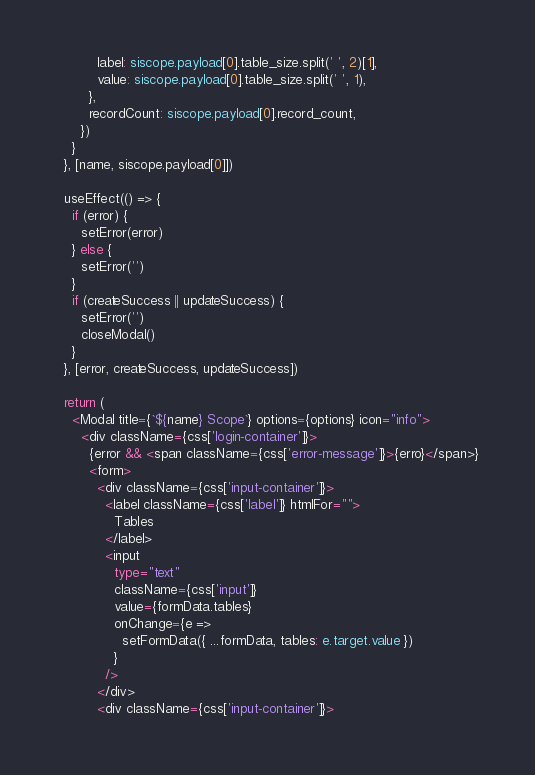Convert code to text. <code><loc_0><loc_0><loc_500><loc_500><_TypeScript_>          label: siscope.payload[0].table_size.split(' ', 2)[1],
          value: siscope.payload[0].table_size.split(' ', 1),
        },
        recordCount: siscope.payload[0].record_count,
      })
    }
  }, [name, siscope.payload[0]])

  useEffect(() => {
    if (error) {
      setError(error)
    } else {
      setError('')
    }
    if (createSuccess || updateSuccess) {
      setError('')
      closeModal()
    }
  }, [error, createSuccess, updateSuccess])

  return (
    <Modal title={`${name} Scope`} options={options} icon="info">
      <div className={css['login-container']}>
        {error && <span className={css['error-message']}>{erro}</span>}
        <form>
          <div className={css['input-container']}>
            <label className={css['label']} htmlFor="">
              Tables
            </label>
            <input
              type="text"
              className={css['input']}
              value={formData.tables}
              onChange={e =>
                setFormData({ ...formData, tables: e.target.value })
              }
            />
          </div>
          <div className={css['input-container']}></code> 